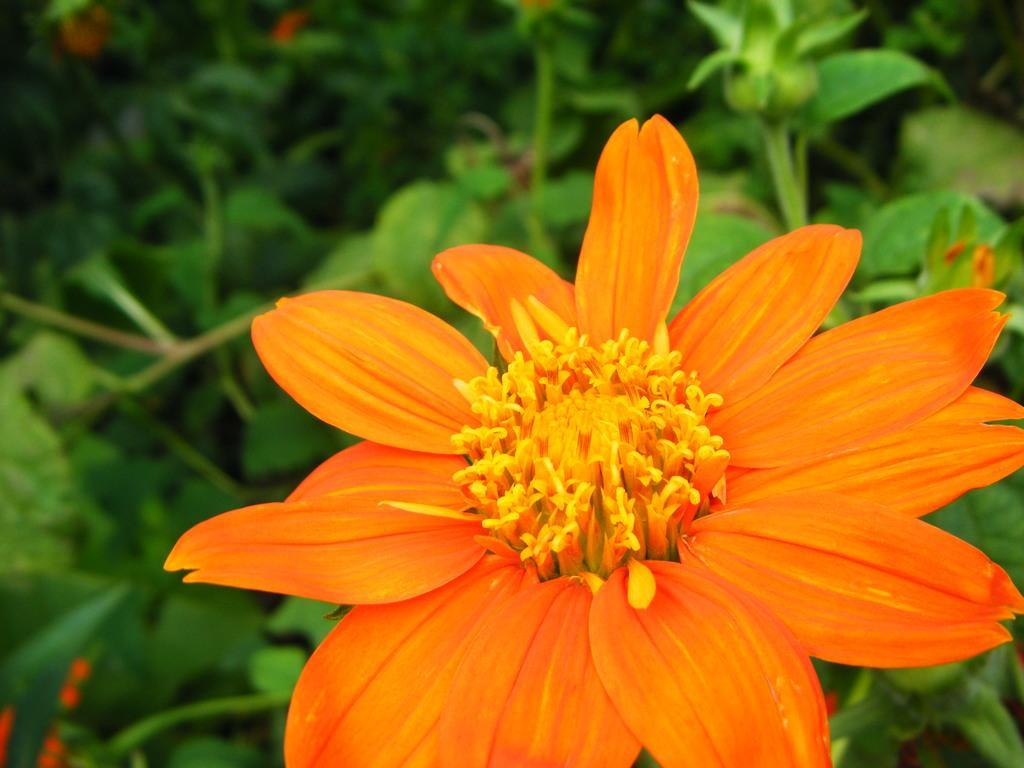Please provide a concise description of this image. In this image we can see flowers to the plants. 